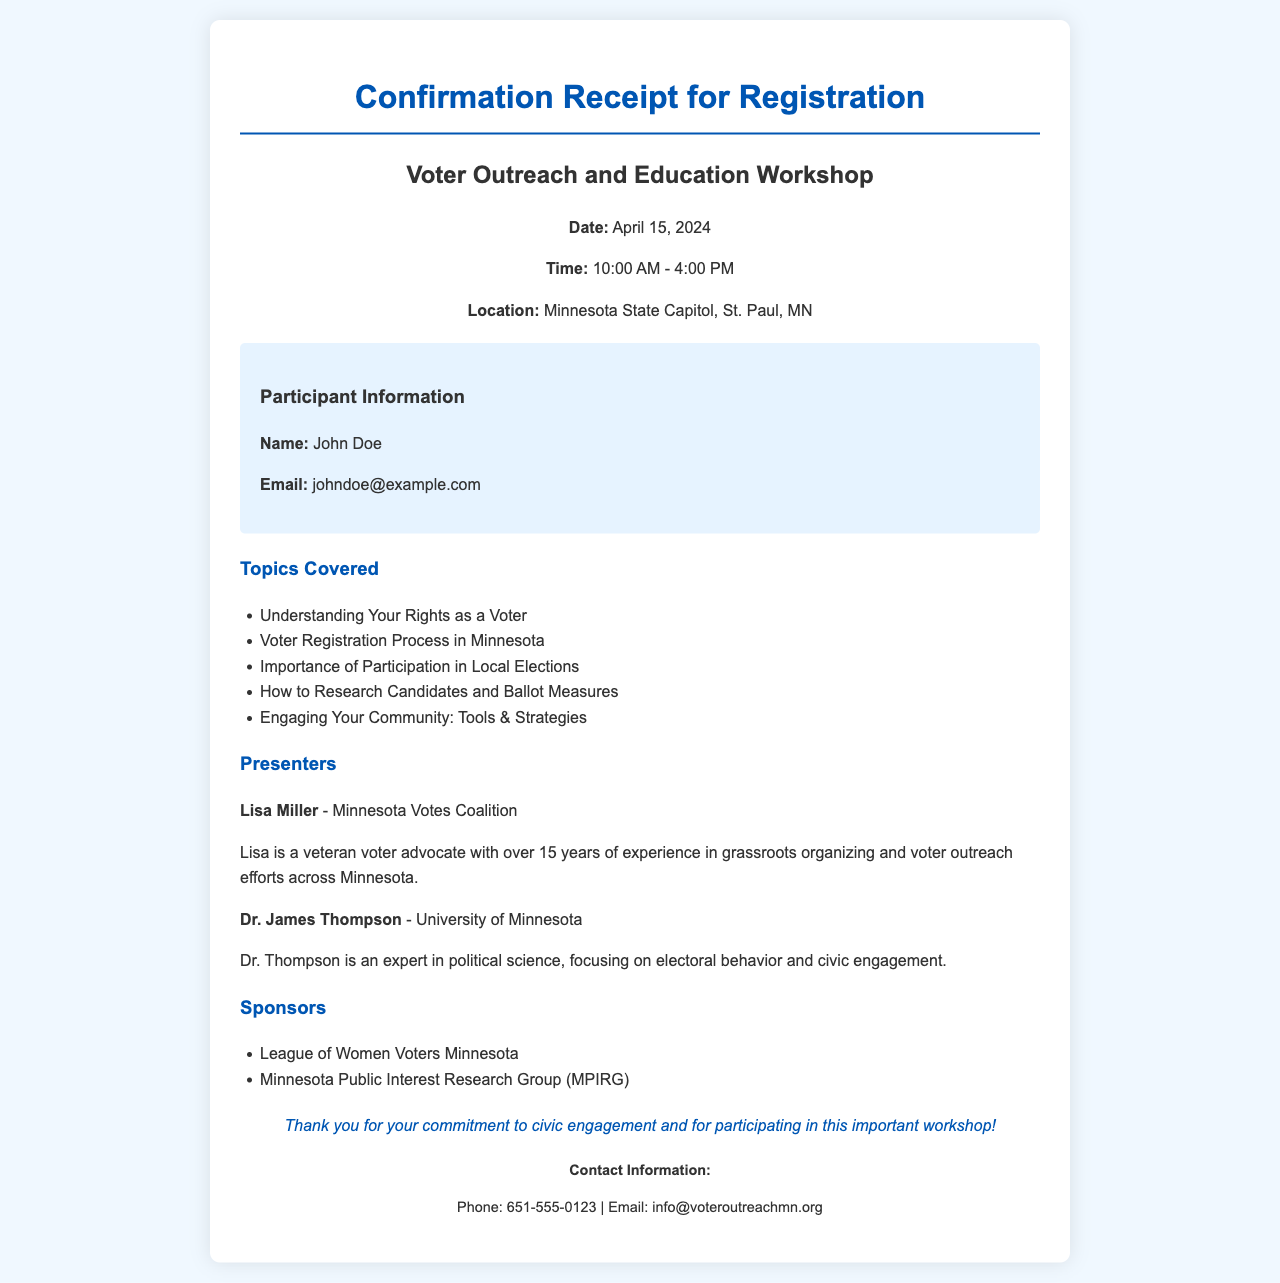what is the date of the workshop? The workshop date is mentioned in the document as April 15, 2024.
Answer: April 15, 2024 what time does the workshop start? The document specifies the workshop start time as 10:00 AM.
Answer: 10:00 AM who is one of the presenters? One of the presenters listed in the document is Lisa Miller.
Answer: Lisa Miller what is the location of the workshop? The location for the workshop is provided as Minnesota State Capitol, St. Paul, MN.
Answer: Minnesota State Capitol, St. Paul, MN how many topics are covered in the workshop? The document lists five topics covered in the workshop.
Answer: Five what is one sponsor of the workshop? The document includes the League of Women Voters Minnesota as a sponsor of the workshop.
Answer: League of Women Voters Minnesota who has over 15 years of experience in voter outreach? Lisa Miller is described as having over 15 years of experience in voter outreach efforts.
Answer: Lisa Miller what is the focus of Dr. James Thompson? Dr. James Thompson focuses on electoral behavior and civic engagement according to the document.
Answer: Electoral behavior and civic engagement what is the contact email for the event? The document provides the contact email as info@voteroutreachmn.org.
Answer: info@voteroutreachmn.org 